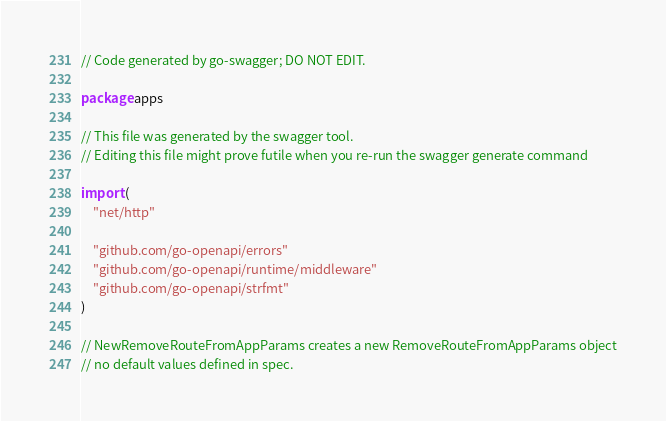<code> <loc_0><loc_0><loc_500><loc_500><_Go_>// Code generated by go-swagger; DO NOT EDIT.

package apps

// This file was generated by the swagger tool.
// Editing this file might prove futile when you re-run the swagger generate command

import (
	"net/http"

	"github.com/go-openapi/errors"
	"github.com/go-openapi/runtime/middleware"
	"github.com/go-openapi/strfmt"
)

// NewRemoveRouteFromAppParams creates a new RemoveRouteFromAppParams object
// no default values defined in spec.</code> 